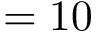Convert formula to latex. <formula><loc_0><loc_0><loc_500><loc_500>= 1 0</formula> 